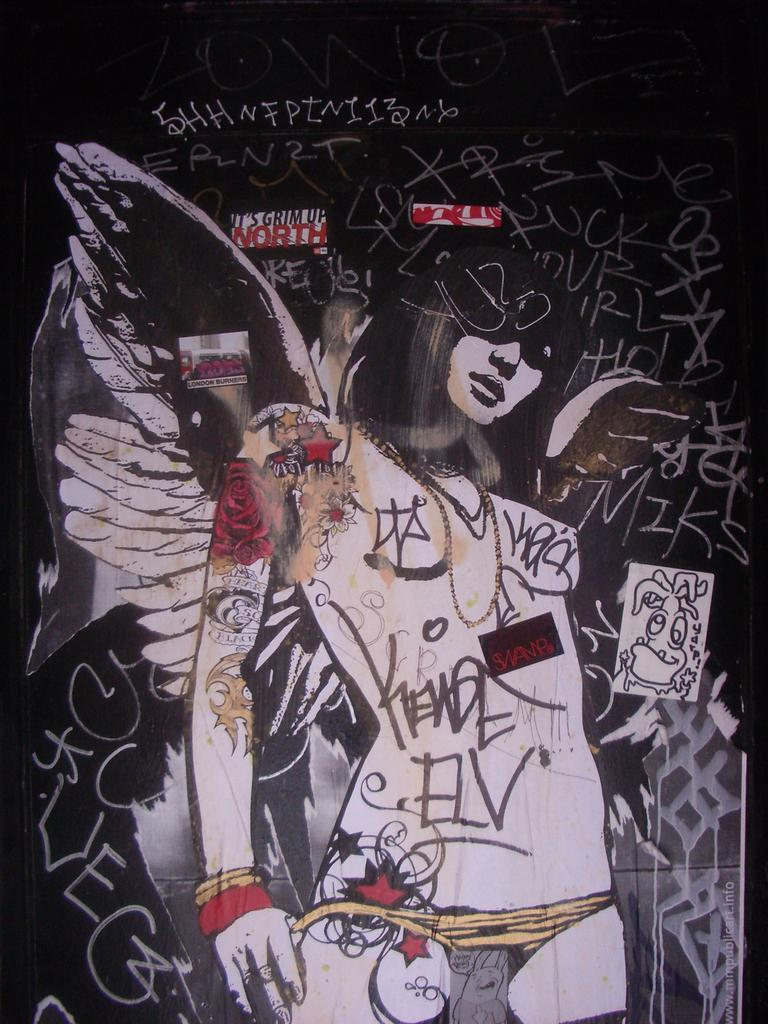What can be seen on the wall in the image? There is a painting on the wall in the image. What else is visible in the image besides the painting? There is text visible in the image. How many yams are present in the image? There are no yams visible in the image. What type of bee can be seen flying near the text in the image? There are no bees present in the image. 